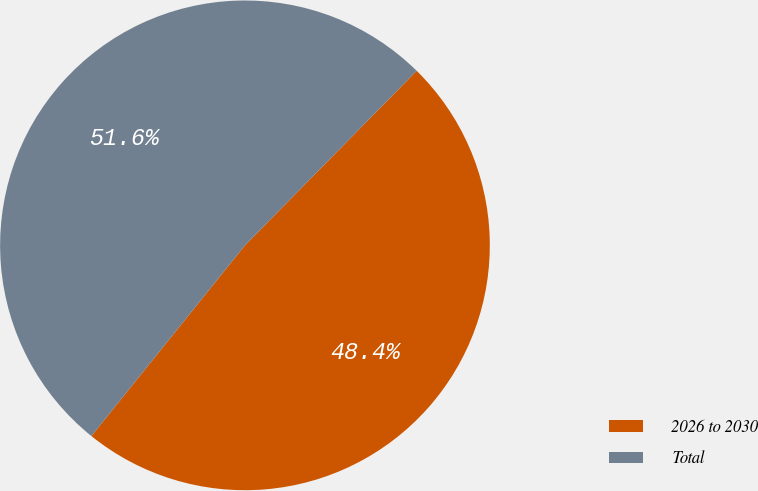<chart> <loc_0><loc_0><loc_500><loc_500><pie_chart><fcel>2026 to 2030<fcel>Total<nl><fcel>48.42%<fcel>51.58%<nl></chart> 